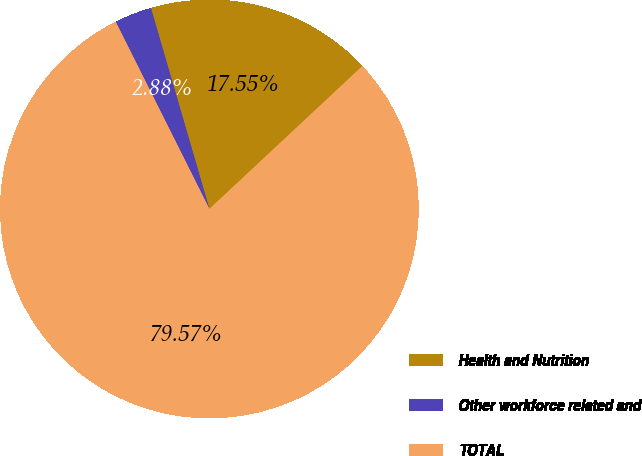<chart> <loc_0><loc_0><loc_500><loc_500><pie_chart><fcel>Health and Nutrition<fcel>Other workforce related and<fcel>TOTAL<nl><fcel>17.55%<fcel>2.88%<fcel>79.57%<nl></chart> 